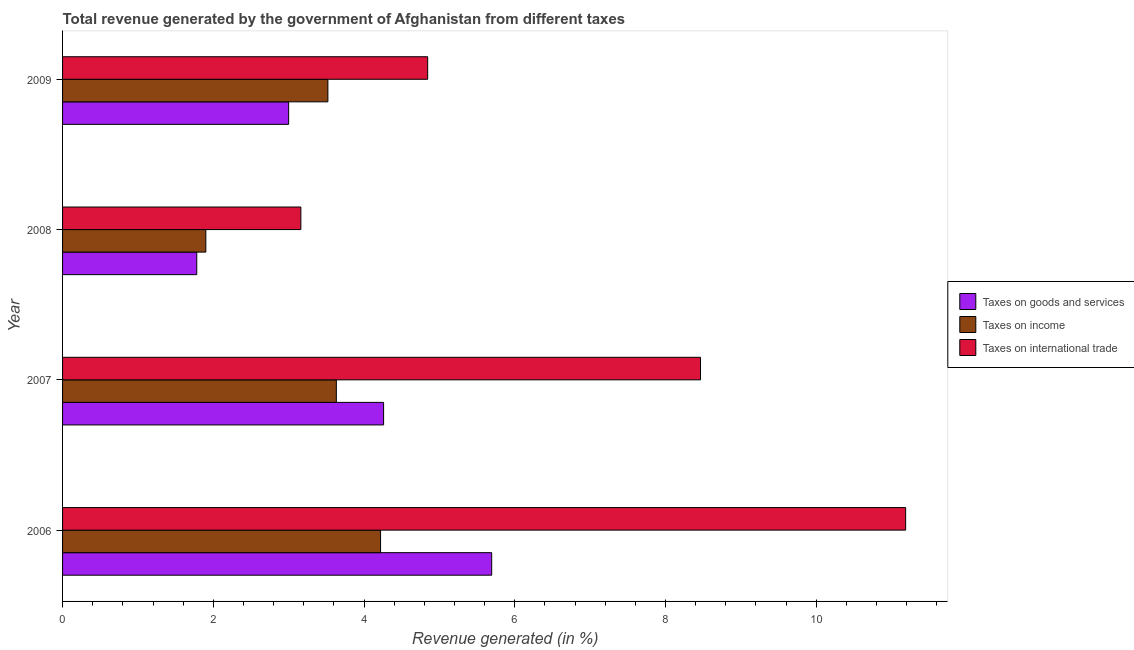How many different coloured bars are there?
Keep it short and to the point. 3. How many groups of bars are there?
Offer a terse response. 4. How many bars are there on the 4th tick from the top?
Your response must be concise. 3. How many bars are there on the 1st tick from the bottom?
Provide a short and direct response. 3. What is the label of the 1st group of bars from the top?
Make the answer very short. 2009. What is the percentage of revenue generated by taxes on goods and services in 2006?
Your answer should be very brief. 5.69. Across all years, what is the maximum percentage of revenue generated by taxes on income?
Your answer should be very brief. 4.22. Across all years, what is the minimum percentage of revenue generated by taxes on income?
Your answer should be compact. 1.9. In which year was the percentage of revenue generated by taxes on income maximum?
Your answer should be compact. 2006. In which year was the percentage of revenue generated by taxes on goods and services minimum?
Provide a succinct answer. 2008. What is the total percentage of revenue generated by tax on international trade in the graph?
Ensure brevity in your answer.  27.66. What is the difference between the percentage of revenue generated by tax on international trade in 2006 and that in 2007?
Give a very brief answer. 2.72. What is the difference between the percentage of revenue generated by taxes on goods and services in 2007 and the percentage of revenue generated by taxes on income in 2008?
Ensure brevity in your answer.  2.36. What is the average percentage of revenue generated by taxes on income per year?
Ensure brevity in your answer.  3.32. In the year 2007, what is the difference between the percentage of revenue generated by tax on international trade and percentage of revenue generated by taxes on income?
Your answer should be compact. 4.83. What is the ratio of the percentage of revenue generated by taxes on income in 2006 to that in 2008?
Provide a succinct answer. 2.22. Is the percentage of revenue generated by taxes on goods and services in 2006 less than that in 2007?
Keep it short and to the point. No. Is the difference between the percentage of revenue generated by tax on international trade in 2006 and 2008 greater than the difference between the percentage of revenue generated by taxes on goods and services in 2006 and 2008?
Your response must be concise. Yes. What is the difference between the highest and the second highest percentage of revenue generated by taxes on income?
Make the answer very short. 0.59. What is the difference between the highest and the lowest percentage of revenue generated by tax on international trade?
Give a very brief answer. 8.02. In how many years, is the percentage of revenue generated by tax on international trade greater than the average percentage of revenue generated by tax on international trade taken over all years?
Your answer should be compact. 2. What does the 1st bar from the top in 2008 represents?
Offer a terse response. Taxes on international trade. What does the 3rd bar from the bottom in 2007 represents?
Give a very brief answer. Taxes on international trade. Is it the case that in every year, the sum of the percentage of revenue generated by taxes on goods and services and percentage of revenue generated by taxes on income is greater than the percentage of revenue generated by tax on international trade?
Provide a short and direct response. No. What is the difference between two consecutive major ticks on the X-axis?
Ensure brevity in your answer.  2. Does the graph contain any zero values?
Your response must be concise. No. Does the graph contain grids?
Ensure brevity in your answer.  No. Where does the legend appear in the graph?
Offer a terse response. Center right. How are the legend labels stacked?
Ensure brevity in your answer.  Vertical. What is the title of the graph?
Make the answer very short. Total revenue generated by the government of Afghanistan from different taxes. What is the label or title of the X-axis?
Your response must be concise. Revenue generated (in %). What is the label or title of the Y-axis?
Provide a short and direct response. Year. What is the Revenue generated (in %) of Taxes on goods and services in 2006?
Provide a short and direct response. 5.69. What is the Revenue generated (in %) of Taxes on income in 2006?
Keep it short and to the point. 4.22. What is the Revenue generated (in %) in Taxes on international trade in 2006?
Keep it short and to the point. 11.19. What is the Revenue generated (in %) of Taxes on goods and services in 2007?
Offer a terse response. 4.26. What is the Revenue generated (in %) in Taxes on income in 2007?
Provide a succinct answer. 3.63. What is the Revenue generated (in %) in Taxes on international trade in 2007?
Provide a short and direct response. 8.46. What is the Revenue generated (in %) in Taxes on goods and services in 2008?
Ensure brevity in your answer.  1.78. What is the Revenue generated (in %) in Taxes on income in 2008?
Provide a succinct answer. 1.9. What is the Revenue generated (in %) of Taxes on international trade in 2008?
Your answer should be very brief. 3.16. What is the Revenue generated (in %) of Taxes on goods and services in 2009?
Your answer should be compact. 3. What is the Revenue generated (in %) of Taxes on income in 2009?
Your response must be concise. 3.52. What is the Revenue generated (in %) of Taxes on international trade in 2009?
Offer a very short reply. 4.84. Across all years, what is the maximum Revenue generated (in %) of Taxes on goods and services?
Give a very brief answer. 5.69. Across all years, what is the maximum Revenue generated (in %) in Taxes on income?
Ensure brevity in your answer.  4.22. Across all years, what is the maximum Revenue generated (in %) in Taxes on international trade?
Ensure brevity in your answer.  11.19. Across all years, what is the minimum Revenue generated (in %) in Taxes on goods and services?
Provide a short and direct response. 1.78. Across all years, what is the minimum Revenue generated (in %) in Taxes on income?
Give a very brief answer. 1.9. Across all years, what is the minimum Revenue generated (in %) of Taxes on international trade?
Your response must be concise. 3.16. What is the total Revenue generated (in %) in Taxes on goods and services in the graph?
Keep it short and to the point. 14.73. What is the total Revenue generated (in %) in Taxes on income in the graph?
Ensure brevity in your answer.  13.27. What is the total Revenue generated (in %) in Taxes on international trade in the graph?
Your response must be concise. 27.66. What is the difference between the Revenue generated (in %) of Taxes on goods and services in 2006 and that in 2007?
Offer a very short reply. 1.43. What is the difference between the Revenue generated (in %) of Taxes on income in 2006 and that in 2007?
Keep it short and to the point. 0.59. What is the difference between the Revenue generated (in %) in Taxes on international trade in 2006 and that in 2007?
Give a very brief answer. 2.72. What is the difference between the Revenue generated (in %) in Taxes on goods and services in 2006 and that in 2008?
Your response must be concise. 3.91. What is the difference between the Revenue generated (in %) in Taxes on income in 2006 and that in 2008?
Give a very brief answer. 2.32. What is the difference between the Revenue generated (in %) of Taxes on international trade in 2006 and that in 2008?
Ensure brevity in your answer.  8.02. What is the difference between the Revenue generated (in %) in Taxes on goods and services in 2006 and that in 2009?
Keep it short and to the point. 2.69. What is the difference between the Revenue generated (in %) in Taxes on income in 2006 and that in 2009?
Keep it short and to the point. 0.7. What is the difference between the Revenue generated (in %) of Taxes on international trade in 2006 and that in 2009?
Offer a very short reply. 6.34. What is the difference between the Revenue generated (in %) of Taxes on goods and services in 2007 and that in 2008?
Keep it short and to the point. 2.48. What is the difference between the Revenue generated (in %) in Taxes on income in 2007 and that in 2008?
Your answer should be very brief. 1.73. What is the difference between the Revenue generated (in %) in Taxes on international trade in 2007 and that in 2008?
Your response must be concise. 5.3. What is the difference between the Revenue generated (in %) in Taxes on goods and services in 2007 and that in 2009?
Offer a terse response. 1.26. What is the difference between the Revenue generated (in %) in Taxes on income in 2007 and that in 2009?
Your response must be concise. 0.11. What is the difference between the Revenue generated (in %) of Taxes on international trade in 2007 and that in 2009?
Your response must be concise. 3.62. What is the difference between the Revenue generated (in %) in Taxes on goods and services in 2008 and that in 2009?
Ensure brevity in your answer.  -1.22. What is the difference between the Revenue generated (in %) of Taxes on income in 2008 and that in 2009?
Offer a terse response. -1.62. What is the difference between the Revenue generated (in %) of Taxes on international trade in 2008 and that in 2009?
Ensure brevity in your answer.  -1.68. What is the difference between the Revenue generated (in %) of Taxes on goods and services in 2006 and the Revenue generated (in %) of Taxes on income in 2007?
Provide a short and direct response. 2.06. What is the difference between the Revenue generated (in %) of Taxes on goods and services in 2006 and the Revenue generated (in %) of Taxes on international trade in 2007?
Provide a succinct answer. -2.77. What is the difference between the Revenue generated (in %) of Taxes on income in 2006 and the Revenue generated (in %) of Taxes on international trade in 2007?
Make the answer very short. -4.25. What is the difference between the Revenue generated (in %) in Taxes on goods and services in 2006 and the Revenue generated (in %) in Taxes on income in 2008?
Give a very brief answer. 3.79. What is the difference between the Revenue generated (in %) in Taxes on goods and services in 2006 and the Revenue generated (in %) in Taxes on international trade in 2008?
Your response must be concise. 2.53. What is the difference between the Revenue generated (in %) of Taxes on income in 2006 and the Revenue generated (in %) of Taxes on international trade in 2008?
Offer a terse response. 1.06. What is the difference between the Revenue generated (in %) in Taxes on goods and services in 2006 and the Revenue generated (in %) in Taxes on income in 2009?
Your answer should be very brief. 2.17. What is the difference between the Revenue generated (in %) in Taxes on goods and services in 2006 and the Revenue generated (in %) in Taxes on international trade in 2009?
Your response must be concise. 0.85. What is the difference between the Revenue generated (in %) in Taxes on income in 2006 and the Revenue generated (in %) in Taxes on international trade in 2009?
Ensure brevity in your answer.  -0.62. What is the difference between the Revenue generated (in %) in Taxes on goods and services in 2007 and the Revenue generated (in %) in Taxes on income in 2008?
Offer a terse response. 2.36. What is the difference between the Revenue generated (in %) in Taxes on goods and services in 2007 and the Revenue generated (in %) in Taxes on international trade in 2008?
Give a very brief answer. 1.1. What is the difference between the Revenue generated (in %) in Taxes on income in 2007 and the Revenue generated (in %) in Taxes on international trade in 2008?
Provide a short and direct response. 0.47. What is the difference between the Revenue generated (in %) in Taxes on goods and services in 2007 and the Revenue generated (in %) in Taxes on income in 2009?
Your response must be concise. 0.74. What is the difference between the Revenue generated (in %) of Taxes on goods and services in 2007 and the Revenue generated (in %) of Taxes on international trade in 2009?
Provide a short and direct response. -0.58. What is the difference between the Revenue generated (in %) in Taxes on income in 2007 and the Revenue generated (in %) in Taxes on international trade in 2009?
Provide a short and direct response. -1.21. What is the difference between the Revenue generated (in %) in Taxes on goods and services in 2008 and the Revenue generated (in %) in Taxes on income in 2009?
Your response must be concise. -1.74. What is the difference between the Revenue generated (in %) in Taxes on goods and services in 2008 and the Revenue generated (in %) in Taxes on international trade in 2009?
Your answer should be compact. -3.06. What is the difference between the Revenue generated (in %) in Taxes on income in 2008 and the Revenue generated (in %) in Taxes on international trade in 2009?
Your answer should be very brief. -2.94. What is the average Revenue generated (in %) in Taxes on goods and services per year?
Offer a very short reply. 3.68. What is the average Revenue generated (in %) in Taxes on income per year?
Make the answer very short. 3.32. What is the average Revenue generated (in %) of Taxes on international trade per year?
Make the answer very short. 6.91. In the year 2006, what is the difference between the Revenue generated (in %) in Taxes on goods and services and Revenue generated (in %) in Taxes on income?
Your answer should be compact. 1.47. In the year 2006, what is the difference between the Revenue generated (in %) in Taxes on goods and services and Revenue generated (in %) in Taxes on international trade?
Give a very brief answer. -5.49. In the year 2006, what is the difference between the Revenue generated (in %) in Taxes on income and Revenue generated (in %) in Taxes on international trade?
Offer a very short reply. -6.97. In the year 2007, what is the difference between the Revenue generated (in %) in Taxes on goods and services and Revenue generated (in %) in Taxes on income?
Your answer should be compact. 0.63. In the year 2007, what is the difference between the Revenue generated (in %) of Taxes on goods and services and Revenue generated (in %) of Taxes on international trade?
Give a very brief answer. -4.2. In the year 2007, what is the difference between the Revenue generated (in %) in Taxes on income and Revenue generated (in %) in Taxes on international trade?
Give a very brief answer. -4.83. In the year 2008, what is the difference between the Revenue generated (in %) of Taxes on goods and services and Revenue generated (in %) of Taxes on income?
Keep it short and to the point. -0.12. In the year 2008, what is the difference between the Revenue generated (in %) in Taxes on goods and services and Revenue generated (in %) in Taxes on international trade?
Offer a very short reply. -1.38. In the year 2008, what is the difference between the Revenue generated (in %) of Taxes on income and Revenue generated (in %) of Taxes on international trade?
Provide a succinct answer. -1.26. In the year 2009, what is the difference between the Revenue generated (in %) in Taxes on goods and services and Revenue generated (in %) in Taxes on income?
Your answer should be compact. -0.52. In the year 2009, what is the difference between the Revenue generated (in %) of Taxes on goods and services and Revenue generated (in %) of Taxes on international trade?
Keep it short and to the point. -1.84. In the year 2009, what is the difference between the Revenue generated (in %) in Taxes on income and Revenue generated (in %) in Taxes on international trade?
Your answer should be compact. -1.32. What is the ratio of the Revenue generated (in %) of Taxes on goods and services in 2006 to that in 2007?
Your answer should be compact. 1.34. What is the ratio of the Revenue generated (in %) of Taxes on income in 2006 to that in 2007?
Give a very brief answer. 1.16. What is the ratio of the Revenue generated (in %) in Taxes on international trade in 2006 to that in 2007?
Make the answer very short. 1.32. What is the ratio of the Revenue generated (in %) of Taxes on goods and services in 2006 to that in 2008?
Offer a terse response. 3.2. What is the ratio of the Revenue generated (in %) in Taxes on income in 2006 to that in 2008?
Your response must be concise. 2.22. What is the ratio of the Revenue generated (in %) in Taxes on international trade in 2006 to that in 2008?
Make the answer very short. 3.54. What is the ratio of the Revenue generated (in %) in Taxes on goods and services in 2006 to that in 2009?
Your response must be concise. 1.9. What is the ratio of the Revenue generated (in %) of Taxes on income in 2006 to that in 2009?
Make the answer very short. 1.2. What is the ratio of the Revenue generated (in %) in Taxes on international trade in 2006 to that in 2009?
Your answer should be very brief. 2.31. What is the ratio of the Revenue generated (in %) in Taxes on goods and services in 2007 to that in 2008?
Your response must be concise. 2.39. What is the ratio of the Revenue generated (in %) of Taxes on income in 2007 to that in 2008?
Your answer should be compact. 1.91. What is the ratio of the Revenue generated (in %) of Taxes on international trade in 2007 to that in 2008?
Your response must be concise. 2.68. What is the ratio of the Revenue generated (in %) of Taxes on goods and services in 2007 to that in 2009?
Ensure brevity in your answer.  1.42. What is the ratio of the Revenue generated (in %) in Taxes on income in 2007 to that in 2009?
Ensure brevity in your answer.  1.03. What is the ratio of the Revenue generated (in %) in Taxes on international trade in 2007 to that in 2009?
Give a very brief answer. 1.75. What is the ratio of the Revenue generated (in %) of Taxes on goods and services in 2008 to that in 2009?
Your answer should be very brief. 0.59. What is the ratio of the Revenue generated (in %) in Taxes on income in 2008 to that in 2009?
Your answer should be very brief. 0.54. What is the ratio of the Revenue generated (in %) of Taxes on international trade in 2008 to that in 2009?
Give a very brief answer. 0.65. What is the difference between the highest and the second highest Revenue generated (in %) of Taxes on goods and services?
Offer a very short reply. 1.43. What is the difference between the highest and the second highest Revenue generated (in %) in Taxes on income?
Your answer should be compact. 0.59. What is the difference between the highest and the second highest Revenue generated (in %) of Taxes on international trade?
Keep it short and to the point. 2.72. What is the difference between the highest and the lowest Revenue generated (in %) in Taxes on goods and services?
Offer a very short reply. 3.91. What is the difference between the highest and the lowest Revenue generated (in %) of Taxes on income?
Give a very brief answer. 2.32. What is the difference between the highest and the lowest Revenue generated (in %) in Taxes on international trade?
Give a very brief answer. 8.02. 